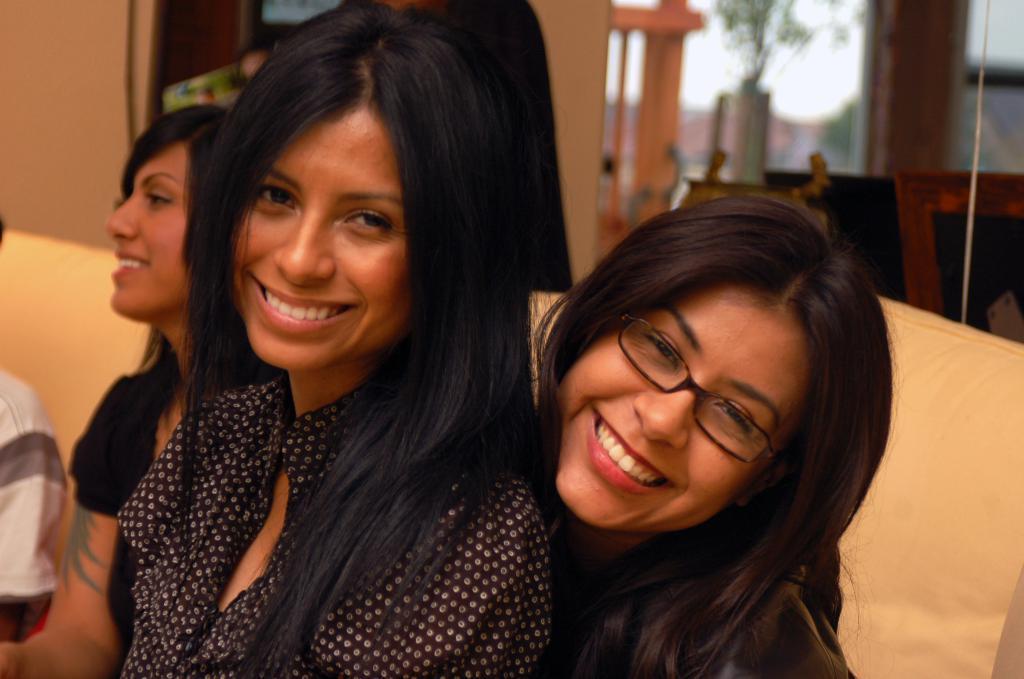Describe this image in one or two sentences. In this image there are three women sitting on the couch. They are smiling. Behind them there is a wall. To the right there are plants. The background is blurry. 